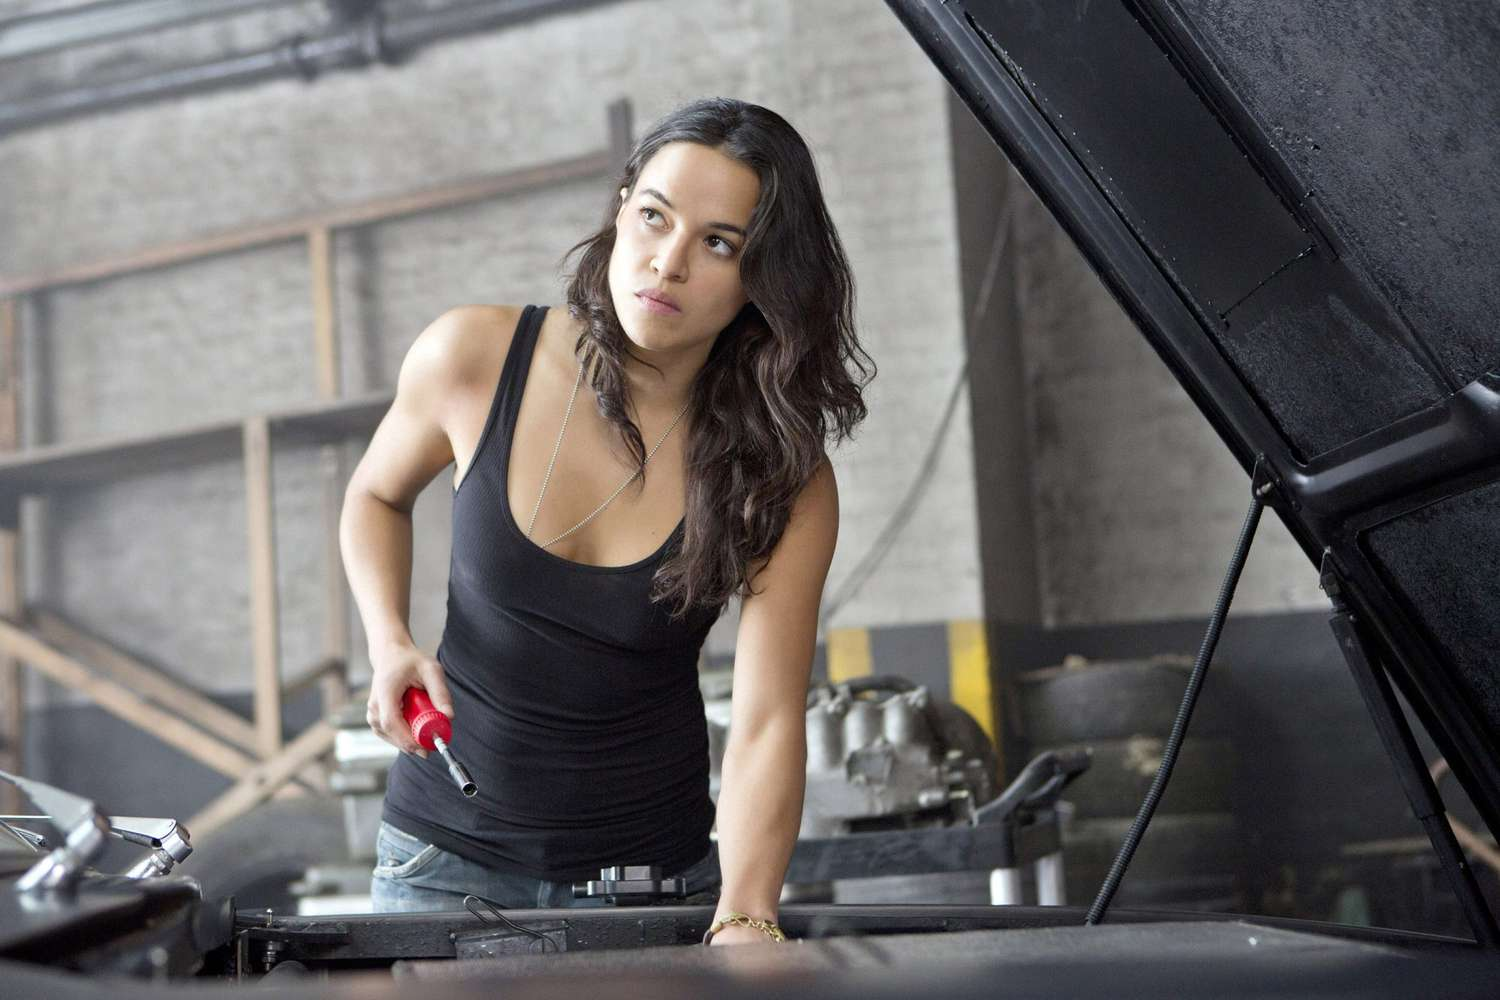Analyze the image in a comprehensive and detailed manner. The image depicts a woman working on a car in a garage. She wears a black tank top and blue jeans, and holds a red wrench in her right hand while leaning over the open car hood. Her expression is one of serious concentration, indicating she is deeply focused on the task at hand. The garage is sparsely equipped, with some tools and car parts visible in the background. The overall atmosphere suggests a dedicated and hardworking individual engaged in an automotive repair activity. 